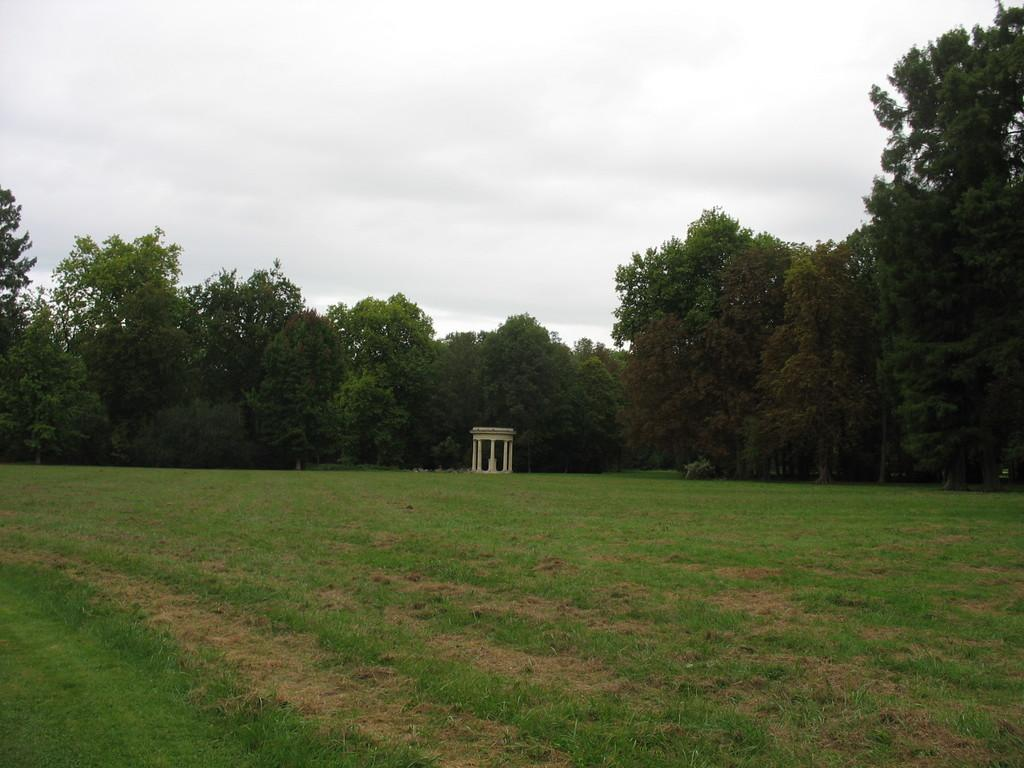What type of vegetation can be seen in the image? There is grass in the image. What can be found on the ground in the image? There are seeds in the image. What type of plants are visible in the image? There are trees in the image. What is visible in the background of the image? The sky is visible in the image. When was the image taken? The image was taken during the day. Where was the image taken? The image was taken on a farm. What type of operation is being performed on the snail in the image? There is no snail present in the image, and therefore no operation is being performed. What month was the image taken in? The month is not mentioned in the provided facts, so it cannot be determined from the image. 